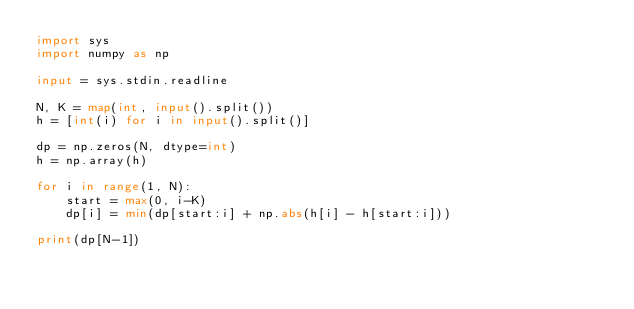Convert code to text. <code><loc_0><loc_0><loc_500><loc_500><_Python_>import sys
import numpy as np

input = sys.stdin.readline

N, K = map(int, input().split())
h = [int(i) for i in input().split()]

dp = np.zeros(N, dtype=int)
h = np.array(h)

for i in range(1, N):
    start = max(0, i-K)
    dp[i] = min(dp[start:i] + np.abs(h[i] - h[start:i]))

print(dp[N-1])</code> 